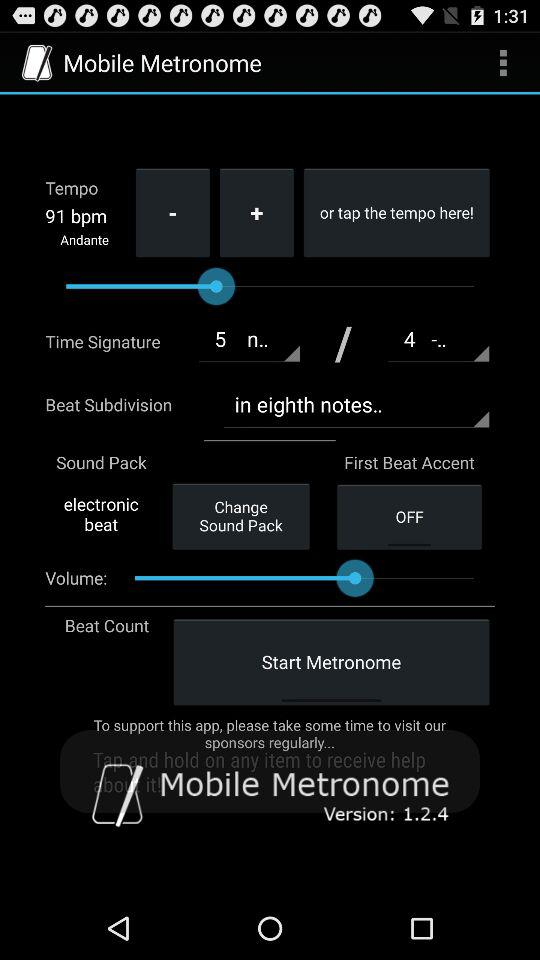Which version is used? The used version is 1.2.4. 